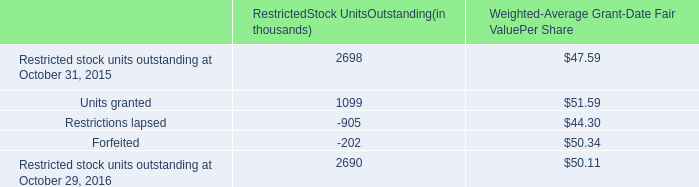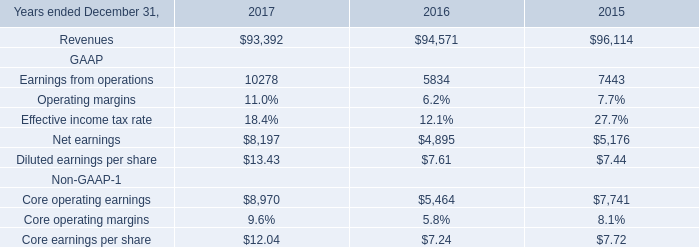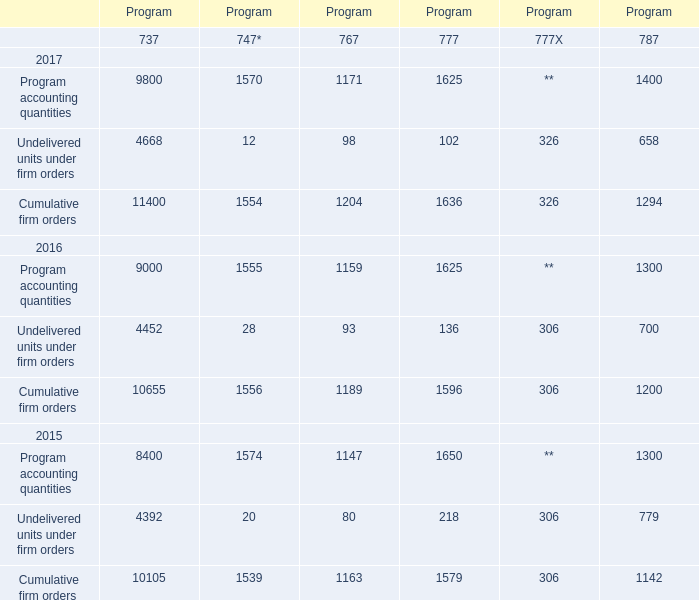What's the sum of Earnings from operations GAAP of 2016, and Cumulative firm orders 2015 of Program ? 
Computations: (5834.0 + 10105.0)
Answer: 15939.0. 